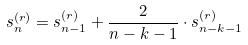Convert formula to latex. <formula><loc_0><loc_0><loc_500><loc_500>s _ { n } ^ { ( r ) } = s _ { n - 1 } ^ { ( r ) } + \frac { 2 } { n - k - 1 } \cdot s _ { n - k - 1 } ^ { ( r ) }</formula> 